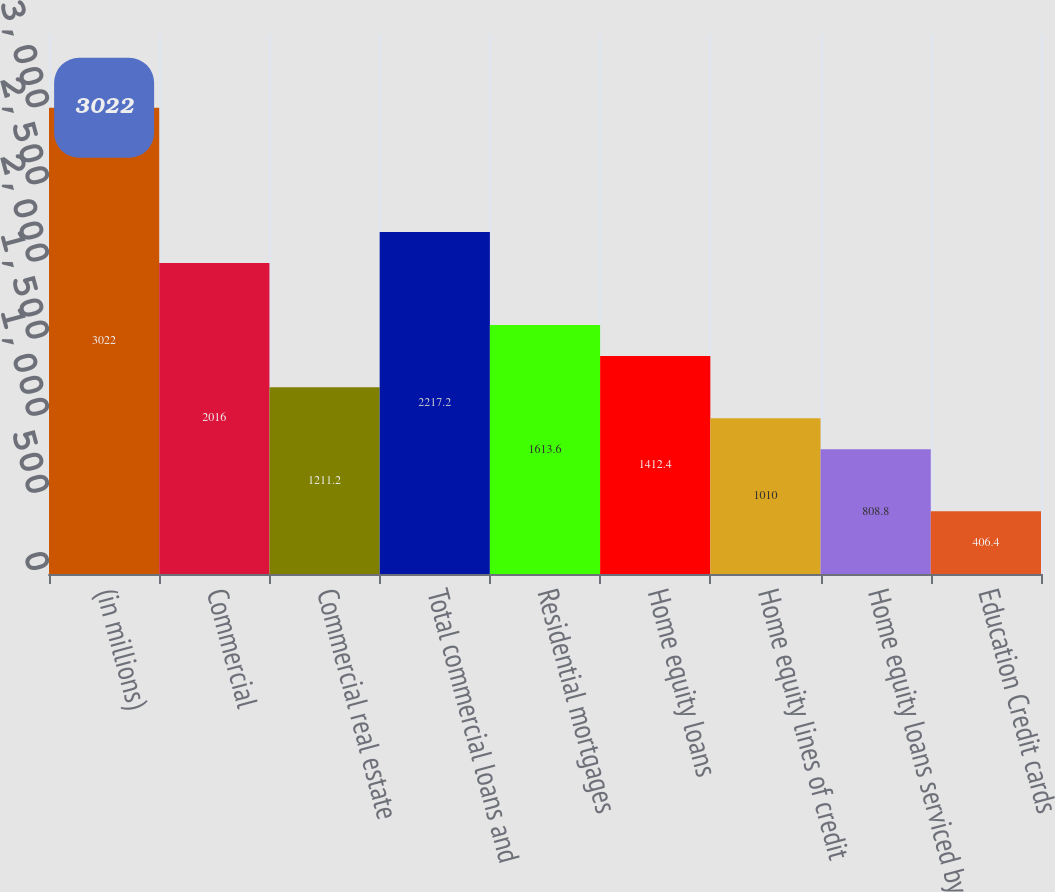<chart> <loc_0><loc_0><loc_500><loc_500><bar_chart><fcel>(in millions)<fcel>Commercial<fcel>Commercial real estate<fcel>Total commercial loans and<fcel>Residential mortgages<fcel>Home equity loans<fcel>Home equity lines of credit<fcel>Home equity loans serviced by<fcel>Education Credit cards<nl><fcel>3022<fcel>2016<fcel>1211.2<fcel>2217.2<fcel>1613.6<fcel>1412.4<fcel>1010<fcel>808.8<fcel>406.4<nl></chart> 